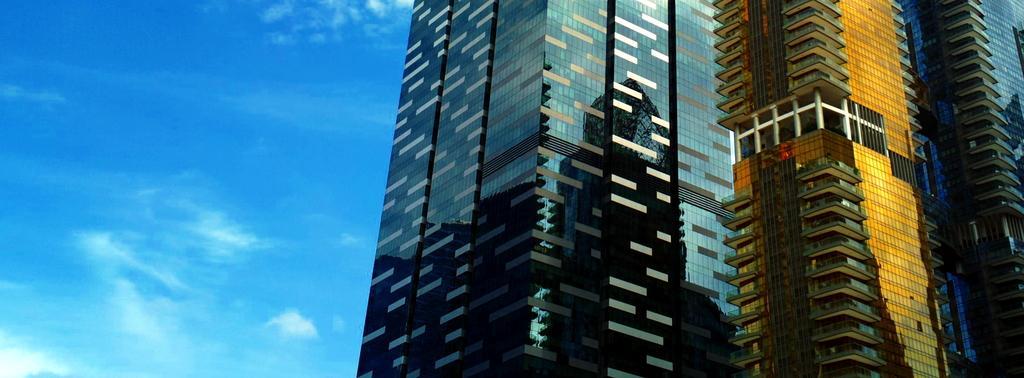Describe this image in one or two sentences. In this image there is a high rise building. 